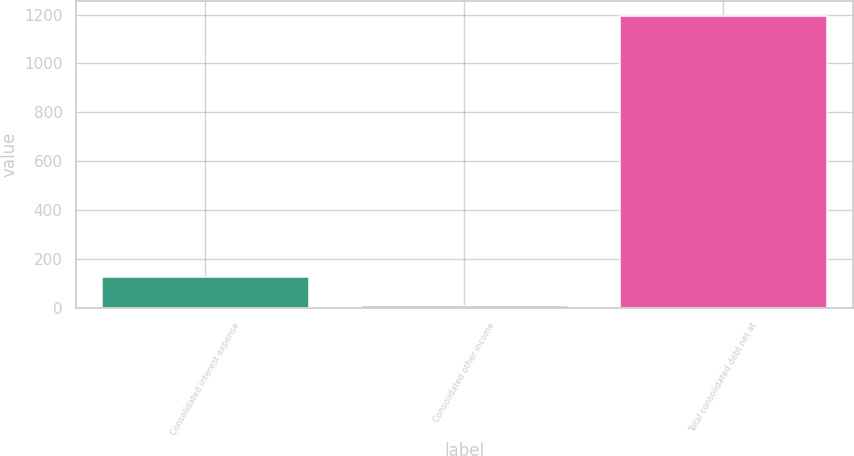Convert chart to OTSL. <chart><loc_0><loc_0><loc_500><loc_500><bar_chart><fcel>Consolidated interest expense<fcel>Consolidated other income<fcel>Total consolidated debt net at<nl><fcel>125.37<fcel>6.5<fcel>1195.2<nl></chart> 